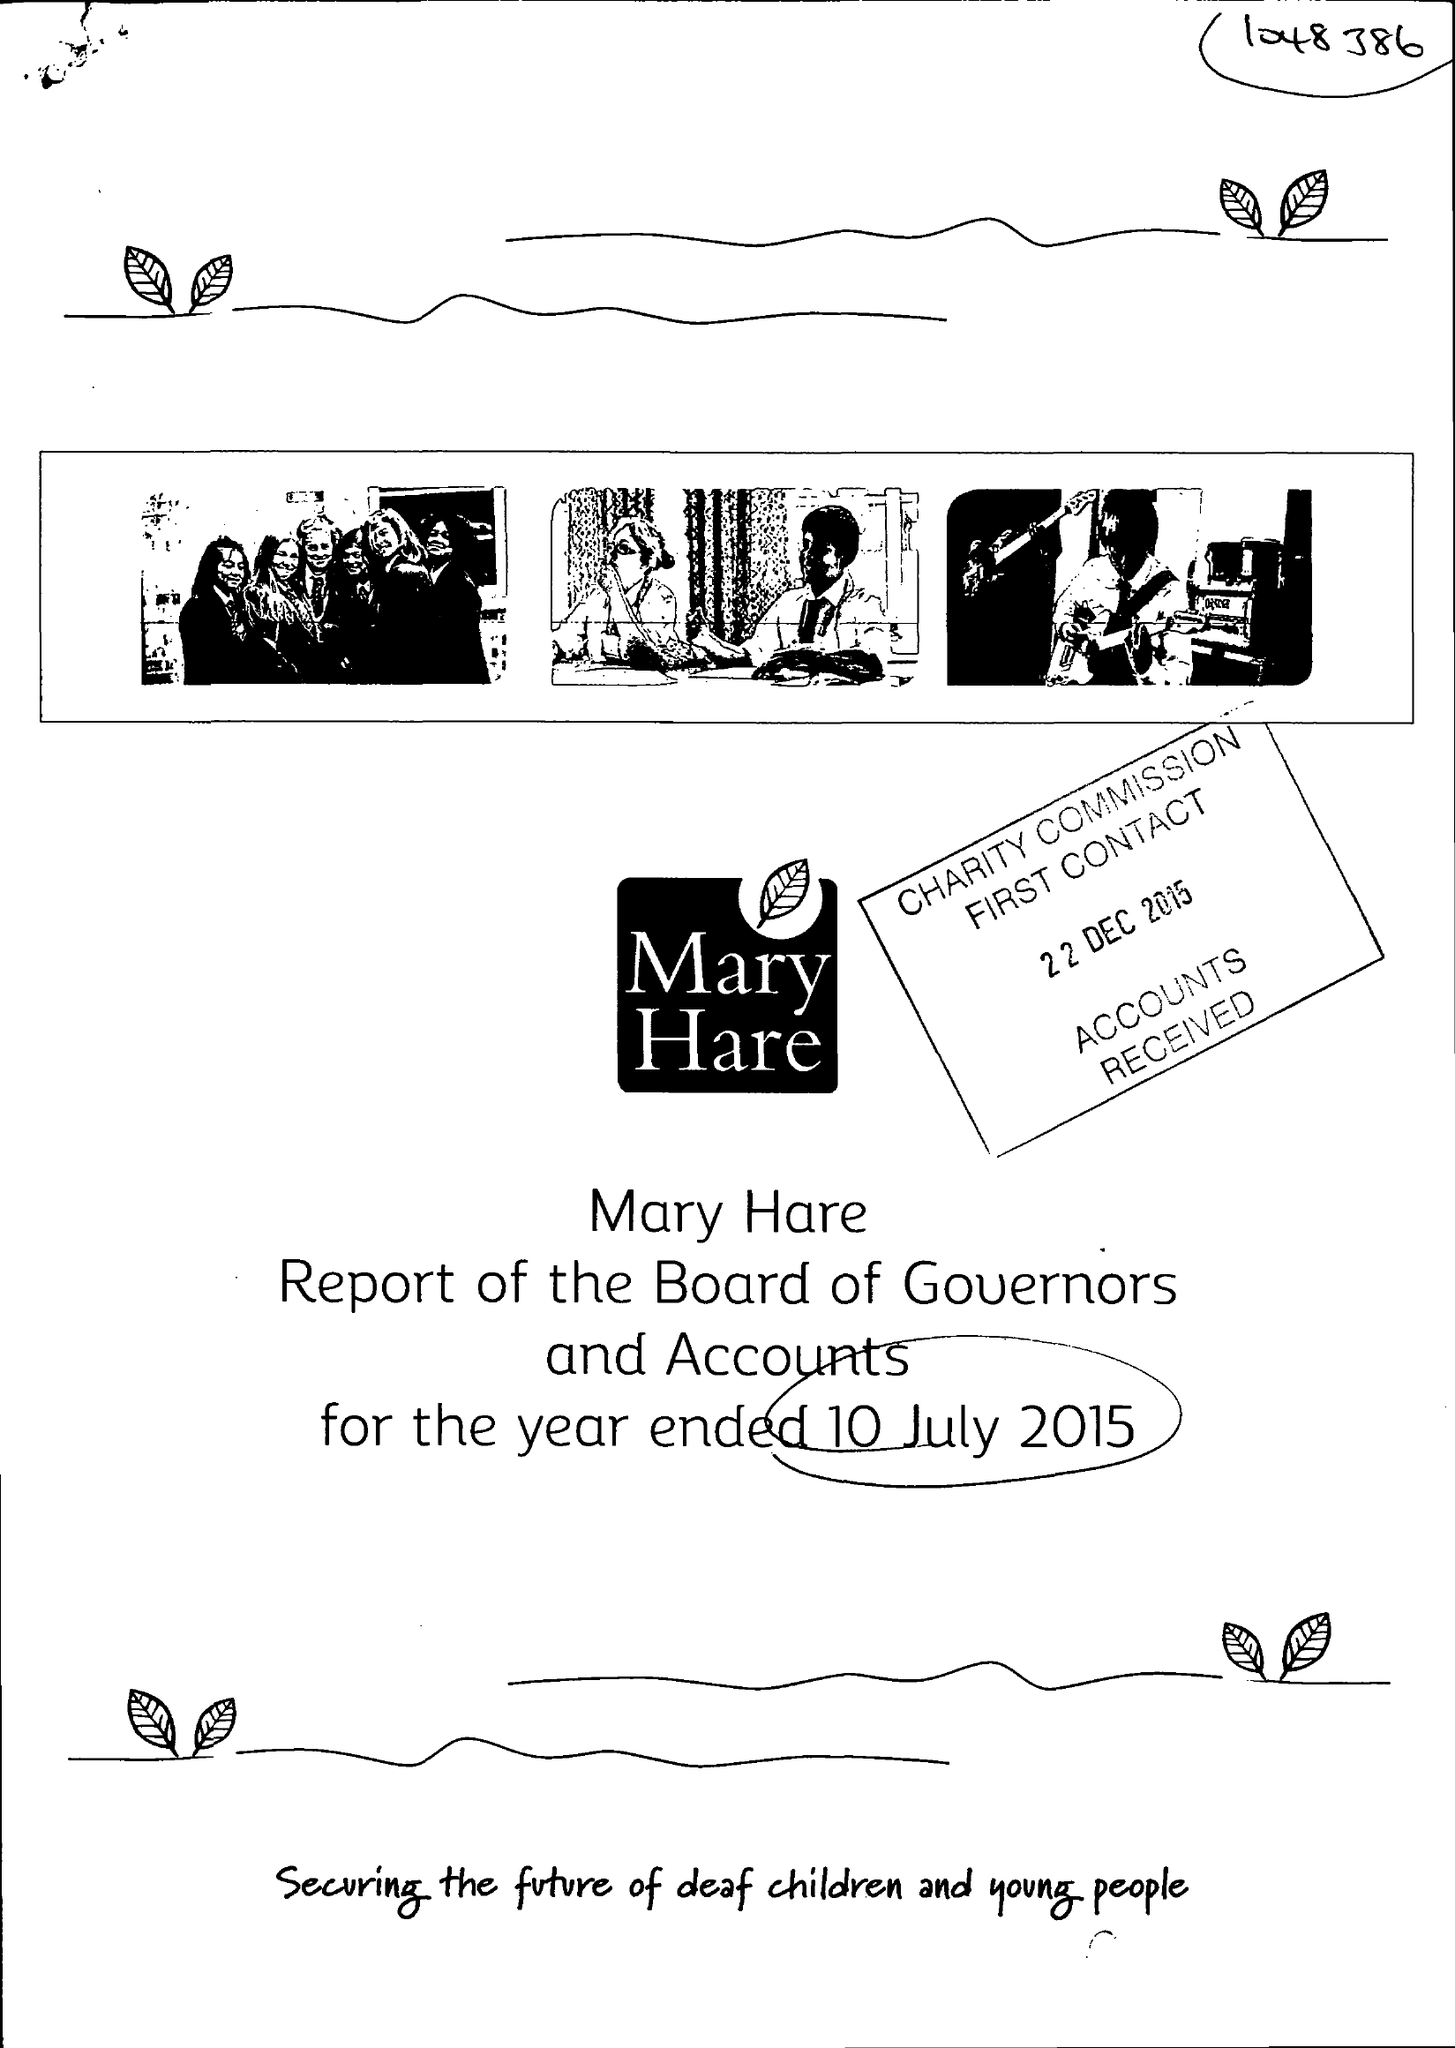What is the value for the report_date?
Answer the question using a single word or phrase. 2015-07-10 